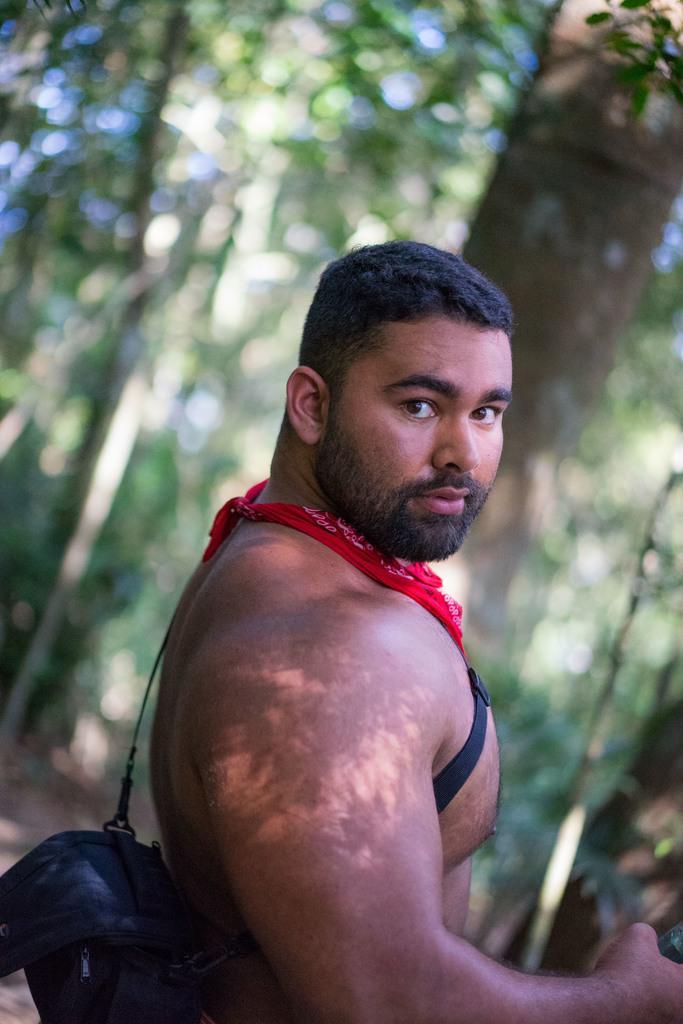Please provide a concise description of this image. In this image I can see one person is wearing the black color bag and there is a red color cloth on the person. In the background there are many trees but it is blurry. 